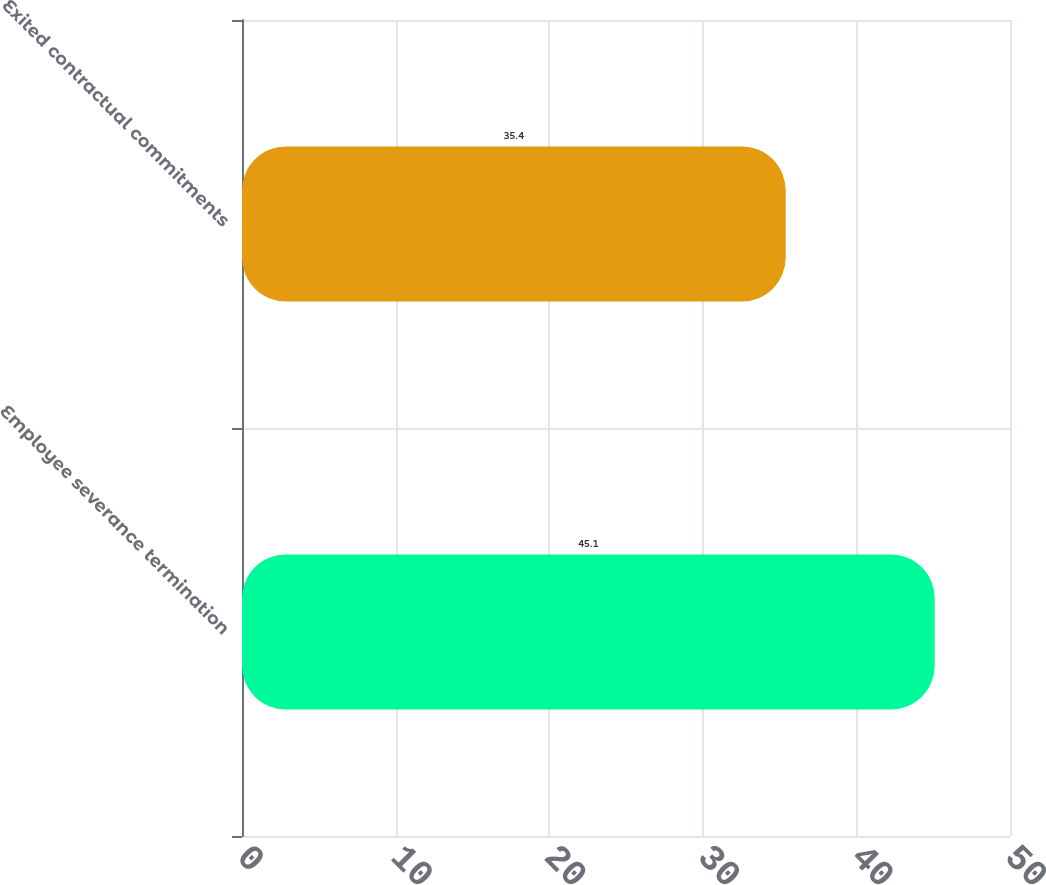Convert chart. <chart><loc_0><loc_0><loc_500><loc_500><bar_chart><fcel>Employee severance termination<fcel>Exited contractual commitments<nl><fcel>45.1<fcel>35.4<nl></chart> 